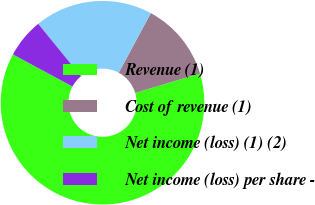Convert chart to OTSL. <chart><loc_0><loc_0><loc_500><loc_500><pie_chart><fcel>Revenue (1)<fcel>Cost of revenue (1)<fcel>Net income (loss) (1) (2)<fcel>Net income (loss) per share -<nl><fcel>62.5%<fcel>12.5%<fcel>18.75%<fcel>6.25%<nl></chart> 